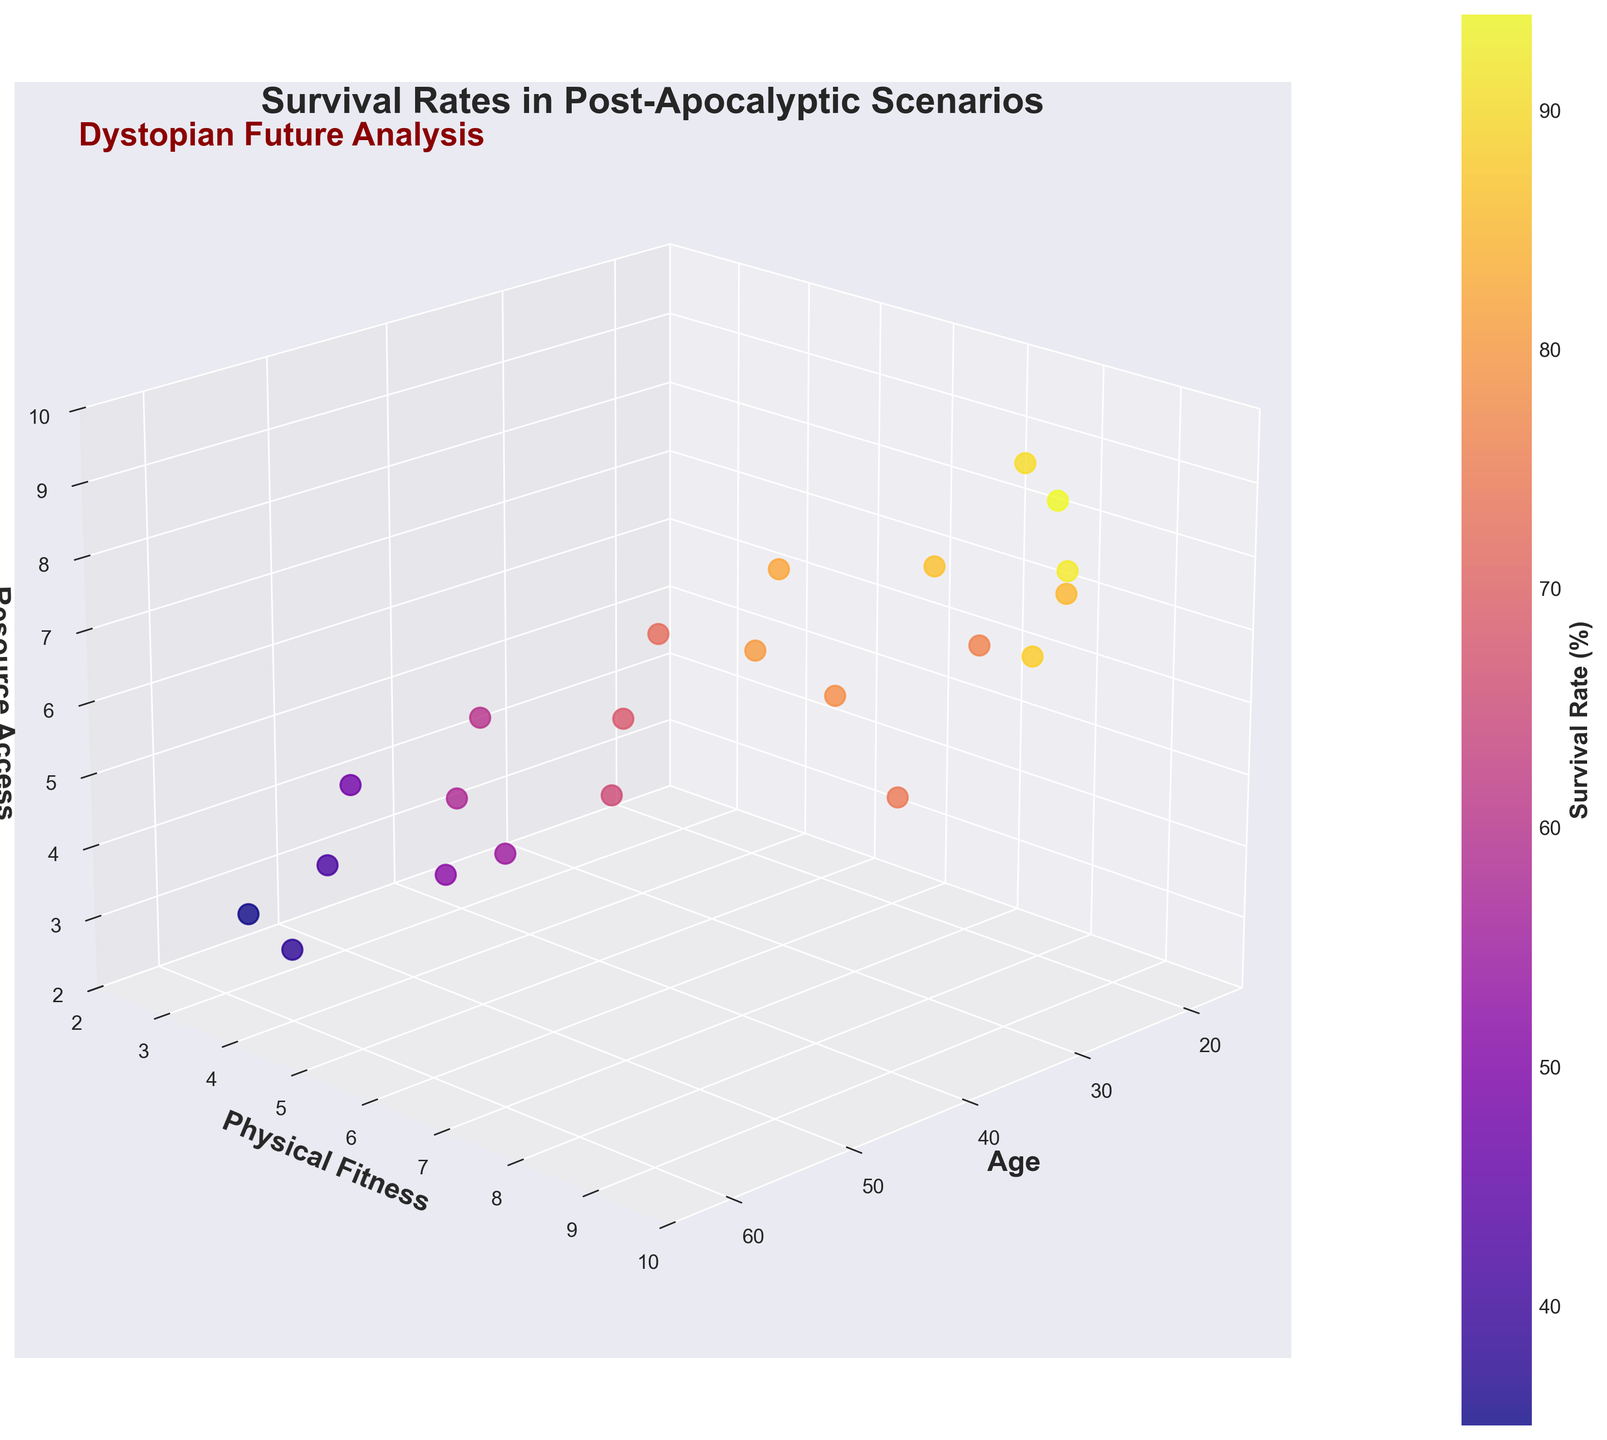What is the range of ages shown on the X-axis? Looking at the X-axis, the minimum age is around 18, and the maximum age is about 60.
Answer: 18 to 60 Which variable is represented by the color gradient? The color gradient represents the Survival Rate, as indicated by the existence of a color bar on the plot labeled "Survival Rate (%)".
Answer: Survival Rate What is the title of the plot? The plot's title is written at the top and reads "Survival Rates in Post-Apocalyptic Scenarios".
Answer: Survival Rates in Post-Apocalyptic Scenarios What is the highest survival rate observed, and what are the corresponding values of age, physical fitness, and resource access? The highest survival rate, as indicated by the brightest color, is 94. The corresponding values of age, physical fitness, and resource access are 26, 9, and 9 respectively, which can be confirmed by locating the brightest point in the plot.
Answer: 94, Age: 26, Physical Fitness: 9, Resource Access: 9 Between the ages of 30 and 40, does higher physical fitness always correspond to higher survival rates? By observing the data points within the age range of 30 to 40, we see varying survival rates even for consistently high physical fitness. For example, at age 32 with fitness 7, the survival rate is 78, whereas at age 33 with fitness 8, the rate is 74, which is lower despite higher physical fitness.
Answer: No How does survival rate generally trend with increasing age? Observing points from younger to older ages, survival rates generally decrease with increasing age, as most lighter-colored (higher survival rate) points are located on the left and darker-colored (lower survival rate) points on the right.
Answer: Decreases Is there any age group where higher physical fitness aligns with lower resource access but still results in a high survival rate? At age 33, the physical fitness is high (8) and resource access is low (5), yet the survival rate is relatively high at 74.
Answer: Yes, age 33 Between ages 50 and 60, which individual has the highest survival rate and what are their physical fitness and resource access levels? Within the age range 50-60, the brightest point is at age 52 with a survival rate of 58. This individual has physical fitness of 5 and resource access of 5.
Answer: Age 52, Physical Fitness: 5, Resource Access: 5 In which age, physical fitness, and resource access combination do we see the lowest survival rate? The darkest point indicating the lowest survival rate is 35, occurring at age 58 with physical fitness 3 and resource access 3.
Answer: Age: 58, Physical Fitness: 3, Resource Access: 3 Compare the survival rates of individuals aged 19 and 55 with similar physical fitness levels. At age 19, with physical fitness of 7, the survival rate is 76. At age 55, with physical fitness of 4, the survival rate is 48. Despite being in different fitness levels, the younger individual has a much higher survival rate.
Answer: Age 19: 76, Age 55: 48 